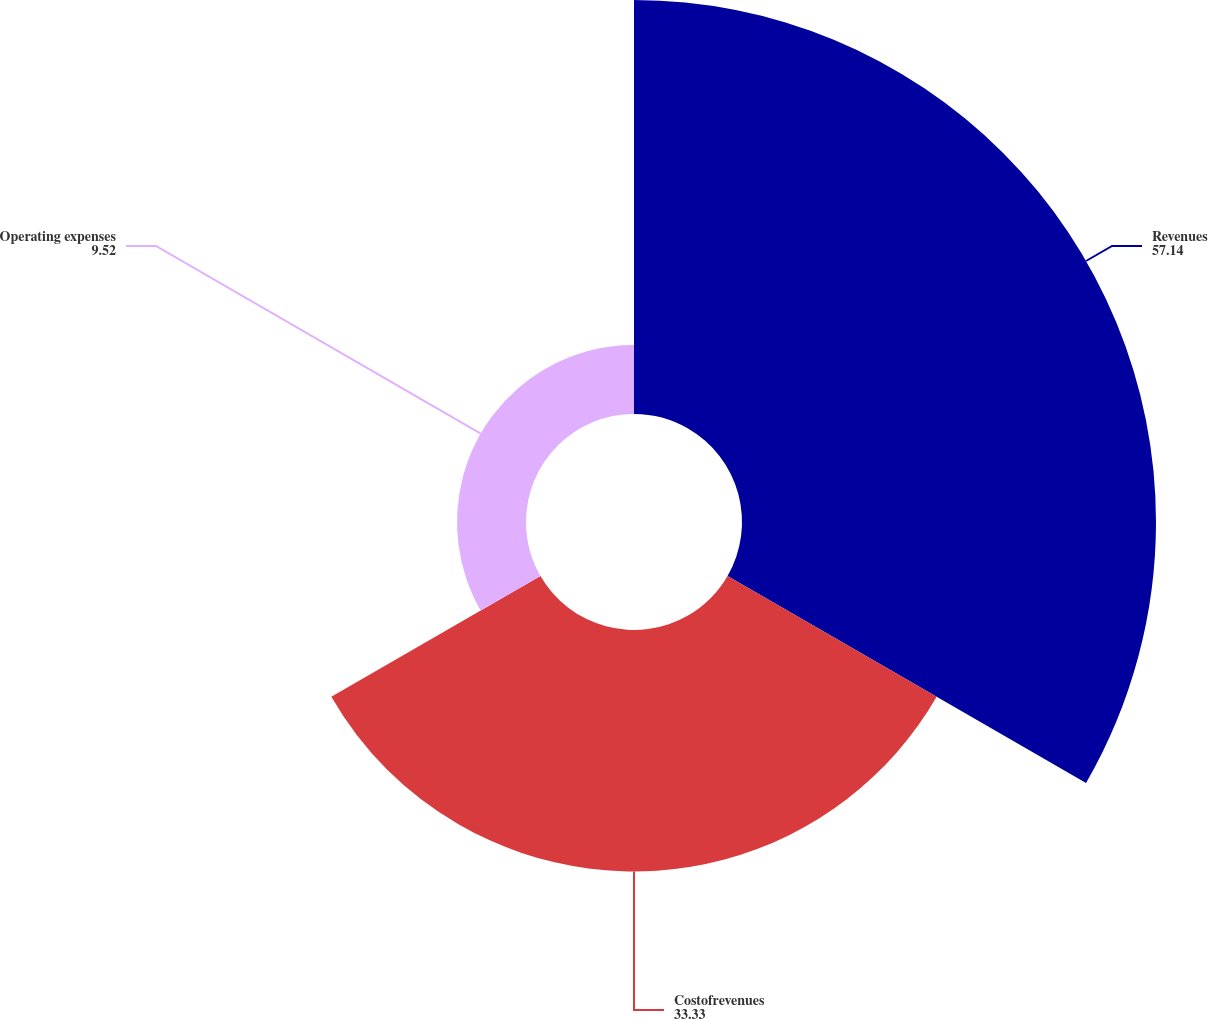Convert chart to OTSL. <chart><loc_0><loc_0><loc_500><loc_500><pie_chart><fcel>Revenues<fcel>Costofrevenues<fcel>Operating expenses<nl><fcel>57.14%<fcel>33.33%<fcel>9.52%<nl></chart> 